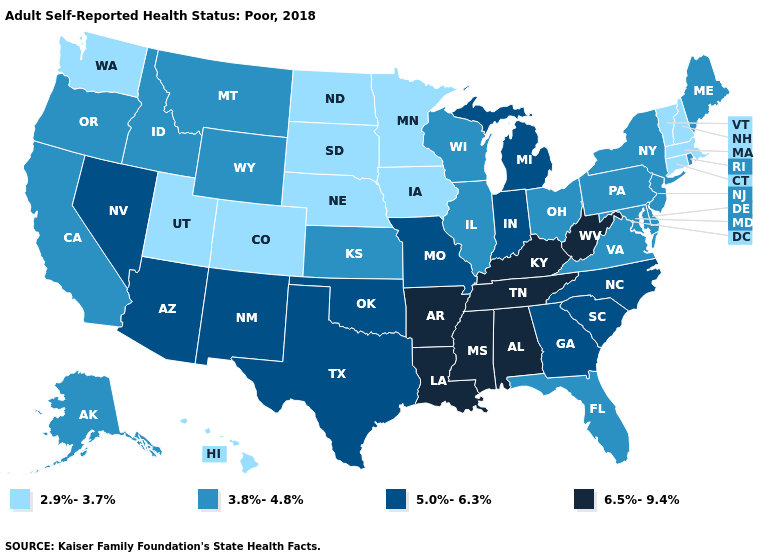What is the highest value in the West ?
Write a very short answer. 5.0%-6.3%. What is the highest value in the Northeast ?
Concise answer only. 3.8%-4.8%. Does Utah have the highest value in the USA?
Answer briefly. No. Name the states that have a value in the range 3.8%-4.8%?
Keep it brief. Alaska, California, Delaware, Florida, Idaho, Illinois, Kansas, Maine, Maryland, Montana, New Jersey, New York, Ohio, Oregon, Pennsylvania, Rhode Island, Virginia, Wisconsin, Wyoming. Name the states that have a value in the range 6.5%-9.4%?
Give a very brief answer. Alabama, Arkansas, Kentucky, Louisiana, Mississippi, Tennessee, West Virginia. Name the states that have a value in the range 5.0%-6.3%?
Quick response, please. Arizona, Georgia, Indiana, Michigan, Missouri, Nevada, New Mexico, North Carolina, Oklahoma, South Carolina, Texas. Name the states that have a value in the range 6.5%-9.4%?
Give a very brief answer. Alabama, Arkansas, Kentucky, Louisiana, Mississippi, Tennessee, West Virginia. What is the value of Florida?
Be succinct. 3.8%-4.8%. What is the lowest value in the USA?
Keep it brief. 2.9%-3.7%. Name the states that have a value in the range 3.8%-4.8%?
Concise answer only. Alaska, California, Delaware, Florida, Idaho, Illinois, Kansas, Maine, Maryland, Montana, New Jersey, New York, Ohio, Oregon, Pennsylvania, Rhode Island, Virginia, Wisconsin, Wyoming. What is the highest value in the USA?
Quick response, please. 6.5%-9.4%. What is the lowest value in states that border California?
Be succinct. 3.8%-4.8%. Which states hav the highest value in the Northeast?
Keep it brief. Maine, New Jersey, New York, Pennsylvania, Rhode Island. How many symbols are there in the legend?
Give a very brief answer. 4. 